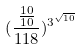Convert formula to latex. <formula><loc_0><loc_0><loc_500><loc_500>( \frac { \frac { 1 0 } { 1 0 } } { 1 1 8 } ) ^ { 3 ^ { \sqrt { 1 0 } } }</formula> 